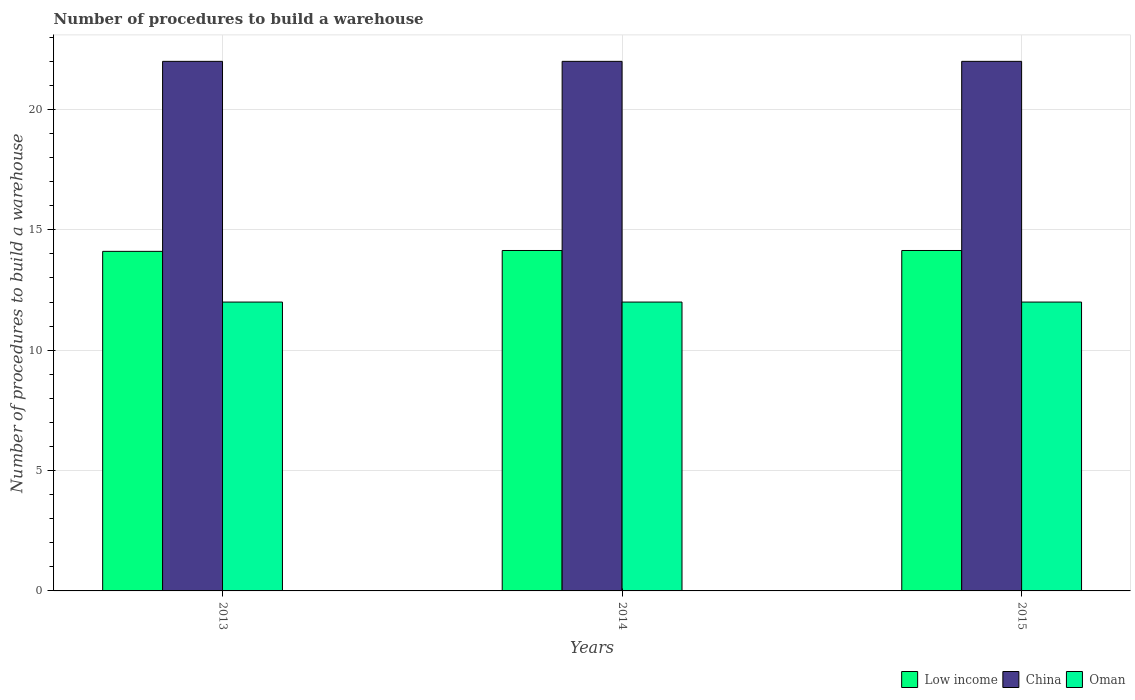How many different coloured bars are there?
Ensure brevity in your answer.  3. Are the number of bars per tick equal to the number of legend labels?
Your response must be concise. Yes. Are the number of bars on each tick of the X-axis equal?
Provide a short and direct response. Yes. How many bars are there on the 2nd tick from the right?
Your response must be concise. 3. What is the label of the 3rd group of bars from the left?
Give a very brief answer. 2015. In how many cases, is the number of bars for a given year not equal to the number of legend labels?
Provide a succinct answer. 0. What is the number of procedures to build a warehouse in in Low income in 2014?
Your answer should be compact. 14.14. Across all years, what is the minimum number of procedures to build a warehouse in in Low income?
Provide a short and direct response. 14.11. What is the difference between the number of procedures to build a warehouse in in Low income in 2013 and that in 2015?
Your answer should be very brief. -0.04. What is the difference between the number of procedures to build a warehouse in in Oman in 2015 and the number of procedures to build a warehouse in in Low income in 2013?
Provide a succinct answer. -2.11. What is the average number of procedures to build a warehouse in in Oman per year?
Give a very brief answer. 12. In the year 2015, what is the difference between the number of procedures to build a warehouse in in China and number of procedures to build a warehouse in in Low income?
Provide a succinct answer. 7.86. In how many years, is the number of procedures to build a warehouse in in Oman greater than 5?
Ensure brevity in your answer.  3. What is the ratio of the number of procedures to build a warehouse in in China in 2013 to that in 2015?
Your answer should be very brief. 1. Is the number of procedures to build a warehouse in in Oman in 2013 less than that in 2014?
Ensure brevity in your answer.  No. What does the 2nd bar from the left in 2015 represents?
Offer a terse response. China. What does the 2nd bar from the right in 2013 represents?
Offer a very short reply. China. How many bars are there?
Make the answer very short. 9. Are all the bars in the graph horizontal?
Ensure brevity in your answer.  No. How many years are there in the graph?
Ensure brevity in your answer.  3. What is the difference between two consecutive major ticks on the Y-axis?
Keep it short and to the point. 5. Does the graph contain grids?
Provide a succinct answer. Yes. How many legend labels are there?
Give a very brief answer. 3. How are the legend labels stacked?
Keep it short and to the point. Horizontal. What is the title of the graph?
Make the answer very short. Number of procedures to build a warehouse. What is the label or title of the Y-axis?
Give a very brief answer. Number of procedures to build a warehouse. What is the Number of procedures to build a warehouse in Low income in 2013?
Ensure brevity in your answer.  14.11. What is the Number of procedures to build a warehouse in Oman in 2013?
Give a very brief answer. 12. What is the Number of procedures to build a warehouse in Low income in 2014?
Provide a succinct answer. 14.14. What is the Number of procedures to build a warehouse in China in 2014?
Offer a very short reply. 22. What is the Number of procedures to build a warehouse of Oman in 2014?
Give a very brief answer. 12. What is the Number of procedures to build a warehouse in Low income in 2015?
Offer a very short reply. 14.14. What is the Number of procedures to build a warehouse of Oman in 2015?
Your answer should be very brief. 12. Across all years, what is the maximum Number of procedures to build a warehouse in Low income?
Provide a succinct answer. 14.14. Across all years, what is the maximum Number of procedures to build a warehouse in China?
Your response must be concise. 22. Across all years, what is the maximum Number of procedures to build a warehouse in Oman?
Ensure brevity in your answer.  12. Across all years, what is the minimum Number of procedures to build a warehouse of Low income?
Your response must be concise. 14.11. What is the total Number of procedures to build a warehouse of Low income in the graph?
Your answer should be compact. 42.39. What is the total Number of procedures to build a warehouse in China in the graph?
Your answer should be compact. 66. What is the total Number of procedures to build a warehouse of Oman in the graph?
Your response must be concise. 36. What is the difference between the Number of procedures to build a warehouse of Low income in 2013 and that in 2014?
Provide a succinct answer. -0.04. What is the difference between the Number of procedures to build a warehouse of China in 2013 and that in 2014?
Ensure brevity in your answer.  0. What is the difference between the Number of procedures to build a warehouse of Oman in 2013 and that in 2014?
Offer a terse response. 0. What is the difference between the Number of procedures to build a warehouse in Low income in 2013 and that in 2015?
Provide a short and direct response. -0.04. What is the difference between the Number of procedures to build a warehouse of Oman in 2013 and that in 2015?
Your response must be concise. 0. What is the difference between the Number of procedures to build a warehouse in Low income in 2013 and the Number of procedures to build a warehouse in China in 2014?
Ensure brevity in your answer.  -7.89. What is the difference between the Number of procedures to build a warehouse in Low income in 2013 and the Number of procedures to build a warehouse in Oman in 2014?
Provide a succinct answer. 2.11. What is the difference between the Number of procedures to build a warehouse of Low income in 2013 and the Number of procedures to build a warehouse of China in 2015?
Your response must be concise. -7.89. What is the difference between the Number of procedures to build a warehouse in Low income in 2013 and the Number of procedures to build a warehouse in Oman in 2015?
Provide a short and direct response. 2.11. What is the difference between the Number of procedures to build a warehouse in China in 2013 and the Number of procedures to build a warehouse in Oman in 2015?
Provide a succinct answer. 10. What is the difference between the Number of procedures to build a warehouse in Low income in 2014 and the Number of procedures to build a warehouse in China in 2015?
Offer a very short reply. -7.86. What is the difference between the Number of procedures to build a warehouse in Low income in 2014 and the Number of procedures to build a warehouse in Oman in 2015?
Provide a short and direct response. 2.14. What is the average Number of procedures to build a warehouse in Low income per year?
Your answer should be compact. 14.13. What is the average Number of procedures to build a warehouse in Oman per year?
Offer a terse response. 12. In the year 2013, what is the difference between the Number of procedures to build a warehouse of Low income and Number of procedures to build a warehouse of China?
Your answer should be very brief. -7.89. In the year 2013, what is the difference between the Number of procedures to build a warehouse in Low income and Number of procedures to build a warehouse in Oman?
Provide a succinct answer. 2.11. In the year 2014, what is the difference between the Number of procedures to build a warehouse of Low income and Number of procedures to build a warehouse of China?
Give a very brief answer. -7.86. In the year 2014, what is the difference between the Number of procedures to build a warehouse in Low income and Number of procedures to build a warehouse in Oman?
Your answer should be compact. 2.14. In the year 2015, what is the difference between the Number of procedures to build a warehouse of Low income and Number of procedures to build a warehouse of China?
Your answer should be very brief. -7.86. In the year 2015, what is the difference between the Number of procedures to build a warehouse of Low income and Number of procedures to build a warehouse of Oman?
Provide a succinct answer. 2.14. What is the ratio of the Number of procedures to build a warehouse in Oman in 2013 to that in 2014?
Provide a succinct answer. 1. What is the ratio of the Number of procedures to build a warehouse of Low income in 2013 to that in 2015?
Give a very brief answer. 1. What is the ratio of the Number of procedures to build a warehouse of China in 2013 to that in 2015?
Offer a very short reply. 1. What is the ratio of the Number of procedures to build a warehouse in Oman in 2013 to that in 2015?
Keep it short and to the point. 1. What is the ratio of the Number of procedures to build a warehouse in Low income in 2014 to that in 2015?
Your answer should be very brief. 1. What is the difference between the highest and the second highest Number of procedures to build a warehouse in China?
Your response must be concise. 0. What is the difference between the highest and the lowest Number of procedures to build a warehouse of Low income?
Make the answer very short. 0.04. What is the difference between the highest and the lowest Number of procedures to build a warehouse of Oman?
Ensure brevity in your answer.  0. 